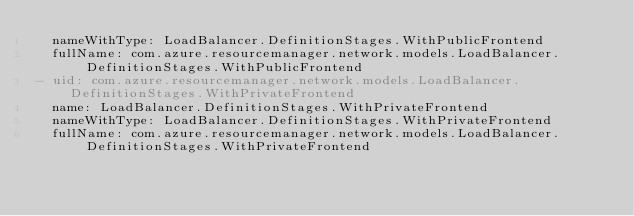Convert code to text. <code><loc_0><loc_0><loc_500><loc_500><_YAML_>  nameWithType: LoadBalancer.DefinitionStages.WithPublicFrontend
  fullName: com.azure.resourcemanager.network.models.LoadBalancer.DefinitionStages.WithPublicFrontend
- uid: com.azure.resourcemanager.network.models.LoadBalancer.DefinitionStages.WithPrivateFrontend
  name: LoadBalancer.DefinitionStages.WithPrivateFrontend
  nameWithType: LoadBalancer.DefinitionStages.WithPrivateFrontend
  fullName: com.azure.resourcemanager.network.models.LoadBalancer.DefinitionStages.WithPrivateFrontend
</code> 